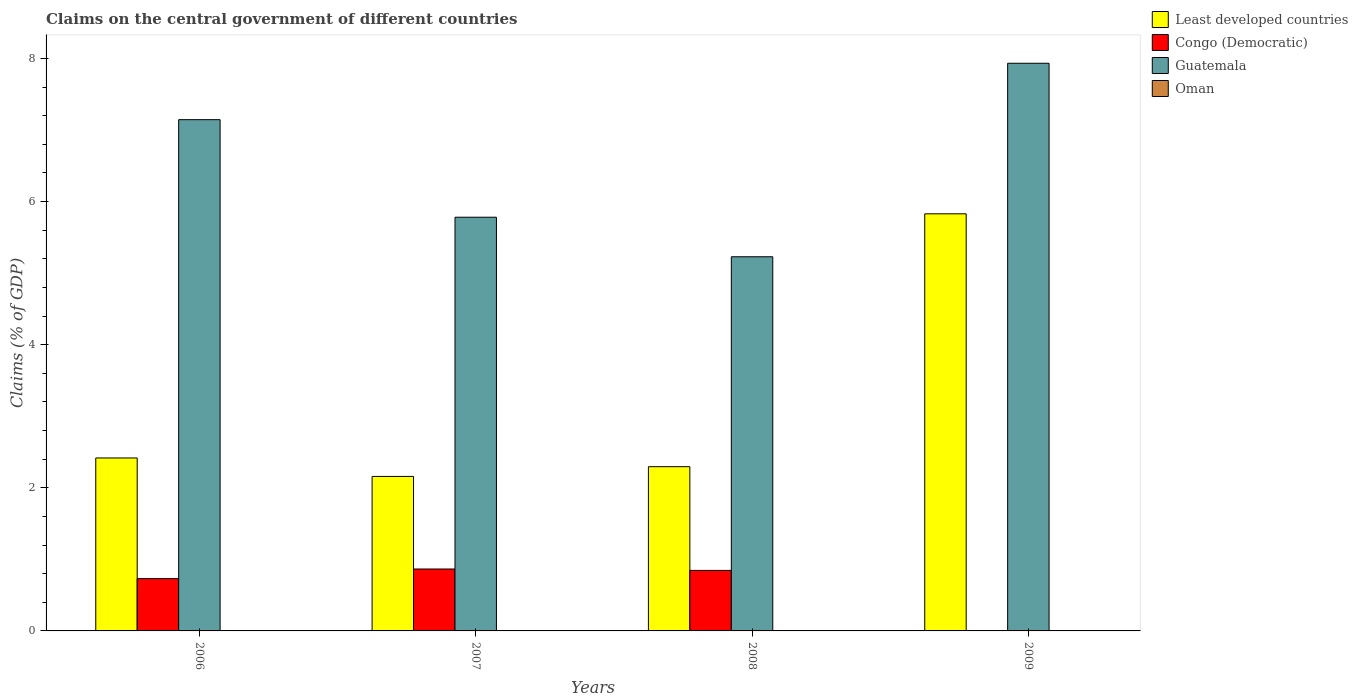How many groups of bars are there?
Your answer should be very brief. 4. Are the number of bars on each tick of the X-axis equal?
Your response must be concise. No. How many bars are there on the 2nd tick from the right?
Keep it short and to the point. 3. What is the percentage of GDP claimed on the central government in Guatemala in 2008?
Keep it short and to the point. 5.23. Across all years, what is the maximum percentage of GDP claimed on the central government in Congo (Democratic)?
Give a very brief answer. 0.87. Across all years, what is the minimum percentage of GDP claimed on the central government in Guatemala?
Provide a short and direct response. 5.23. In which year was the percentage of GDP claimed on the central government in Guatemala maximum?
Provide a short and direct response. 2009. What is the total percentage of GDP claimed on the central government in Congo (Democratic) in the graph?
Offer a terse response. 2.44. What is the difference between the percentage of GDP claimed on the central government in Congo (Democratic) in 2007 and that in 2008?
Your answer should be very brief. 0.02. What is the difference between the percentage of GDP claimed on the central government in Oman in 2007 and the percentage of GDP claimed on the central government in Congo (Democratic) in 2006?
Keep it short and to the point. -0.73. What is the average percentage of GDP claimed on the central government in Oman per year?
Your answer should be compact. 0. In the year 2006, what is the difference between the percentage of GDP claimed on the central government in Least developed countries and percentage of GDP claimed on the central government in Guatemala?
Your response must be concise. -4.73. What is the ratio of the percentage of GDP claimed on the central government in Guatemala in 2006 to that in 2009?
Make the answer very short. 0.9. Is the percentage of GDP claimed on the central government in Least developed countries in 2008 less than that in 2009?
Provide a short and direct response. Yes. Is the difference between the percentage of GDP claimed on the central government in Least developed countries in 2007 and 2008 greater than the difference between the percentage of GDP claimed on the central government in Guatemala in 2007 and 2008?
Keep it short and to the point. No. What is the difference between the highest and the second highest percentage of GDP claimed on the central government in Guatemala?
Provide a succinct answer. 0.79. What is the difference between the highest and the lowest percentage of GDP claimed on the central government in Congo (Democratic)?
Your answer should be compact. 0.87. In how many years, is the percentage of GDP claimed on the central government in Least developed countries greater than the average percentage of GDP claimed on the central government in Least developed countries taken over all years?
Make the answer very short. 1. Is the sum of the percentage of GDP claimed on the central government in Congo (Democratic) in 2007 and 2008 greater than the maximum percentage of GDP claimed on the central government in Oman across all years?
Provide a succinct answer. Yes. Is it the case that in every year, the sum of the percentage of GDP claimed on the central government in Oman and percentage of GDP claimed on the central government in Guatemala is greater than the sum of percentage of GDP claimed on the central government in Least developed countries and percentage of GDP claimed on the central government in Congo (Democratic)?
Offer a very short reply. No. Is it the case that in every year, the sum of the percentage of GDP claimed on the central government in Oman and percentage of GDP claimed on the central government in Congo (Democratic) is greater than the percentage of GDP claimed on the central government in Least developed countries?
Your answer should be compact. No. How many bars are there?
Offer a very short reply. 11. Are the values on the major ticks of Y-axis written in scientific E-notation?
Your answer should be compact. No. Does the graph contain grids?
Make the answer very short. No. How many legend labels are there?
Your response must be concise. 4. What is the title of the graph?
Give a very brief answer. Claims on the central government of different countries. What is the label or title of the X-axis?
Make the answer very short. Years. What is the label or title of the Y-axis?
Make the answer very short. Claims (% of GDP). What is the Claims (% of GDP) of Least developed countries in 2006?
Give a very brief answer. 2.42. What is the Claims (% of GDP) in Congo (Democratic) in 2006?
Offer a very short reply. 0.73. What is the Claims (% of GDP) of Guatemala in 2006?
Your response must be concise. 7.14. What is the Claims (% of GDP) in Least developed countries in 2007?
Offer a very short reply. 2.16. What is the Claims (% of GDP) in Congo (Democratic) in 2007?
Offer a terse response. 0.87. What is the Claims (% of GDP) of Guatemala in 2007?
Offer a very short reply. 5.78. What is the Claims (% of GDP) of Oman in 2007?
Give a very brief answer. 0. What is the Claims (% of GDP) of Least developed countries in 2008?
Make the answer very short. 2.3. What is the Claims (% of GDP) in Congo (Democratic) in 2008?
Your response must be concise. 0.85. What is the Claims (% of GDP) in Guatemala in 2008?
Ensure brevity in your answer.  5.23. What is the Claims (% of GDP) of Oman in 2008?
Give a very brief answer. 0. What is the Claims (% of GDP) in Least developed countries in 2009?
Your response must be concise. 5.83. What is the Claims (% of GDP) in Congo (Democratic) in 2009?
Your response must be concise. 0. What is the Claims (% of GDP) of Guatemala in 2009?
Make the answer very short. 7.93. What is the Claims (% of GDP) in Oman in 2009?
Provide a short and direct response. 0. Across all years, what is the maximum Claims (% of GDP) in Least developed countries?
Give a very brief answer. 5.83. Across all years, what is the maximum Claims (% of GDP) of Congo (Democratic)?
Ensure brevity in your answer.  0.87. Across all years, what is the maximum Claims (% of GDP) of Guatemala?
Keep it short and to the point. 7.93. Across all years, what is the minimum Claims (% of GDP) of Least developed countries?
Ensure brevity in your answer.  2.16. Across all years, what is the minimum Claims (% of GDP) in Guatemala?
Give a very brief answer. 5.23. What is the total Claims (% of GDP) of Least developed countries in the graph?
Your answer should be very brief. 12.7. What is the total Claims (% of GDP) in Congo (Democratic) in the graph?
Offer a terse response. 2.44. What is the total Claims (% of GDP) of Guatemala in the graph?
Make the answer very short. 26.09. What is the difference between the Claims (% of GDP) of Least developed countries in 2006 and that in 2007?
Provide a short and direct response. 0.26. What is the difference between the Claims (% of GDP) of Congo (Democratic) in 2006 and that in 2007?
Offer a very short reply. -0.13. What is the difference between the Claims (% of GDP) in Guatemala in 2006 and that in 2007?
Your answer should be very brief. 1.36. What is the difference between the Claims (% of GDP) of Least developed countries in 2006 and that in 2008?
Keep it short and to the point. 0.12. What is the difference between the Claims (% of GDP) of Congo (Democratic) in 2006 and that in 2008?
Give a very brief answer. -0.11. What is the difference between the Claims (% of GDP) in Guatemala in 2006 and that in 2008?
Ensure brevity in your answer.  1.92. What is the difference between the Claims (% of GDP) of Least developed countries in 2006 and that in 2009?
Offer a terse response. -3.41. What is the difference between the Claims (% of GDP) of Guatemala in 2006 and that in 2009?
Your answer should be compact. -0.79. What is the difference between the Claims (% of GDP) of Least developed countries in 2007 and that in 2008?
Ensure brevity in your answer.  -0.14. What is the difference between the Claims (% of GDP) in Congo (Democratic) in 2007 and that in 2008?
Your response must be concise. 0.02. What is the difference between the Claims (% of GDP) of Guatemala in 2007 and that in 2008?
Give a very brief answer. 0.55. What is the difference between the Claims (% of GDP) of Least developed countries in 2007 and that in 2009?
Make the answer very short. -3.67. What is the difference between the Claims (% of GDP) in Guatemala in 2007 and that in 2009?
Offer a very short reply. -2.15. What is the difference between the Claims (% of GDP) of Least developed countries in 2008 and that in 2009?
Offer a terse response. -3.53. What is the difference between the Claims (% of GDP) in Guatemala in 2008 and that in 2009?
Keep it short and to the point. -2.7. What is the difference between the Claims (% of GDP) in Least developed countries in 2006 and the Claims (% of GDP) in Congo (Democratic) in 2007?
Provide a succinct answer. 1.55. What is the difference between the Claims (% of GDP) in Least developed countries in 2006 and the Claims (% of GDP) in Guatemala in 2007?
Provide a short and direct response. -3.36. What is the difference between the Claims (% of GDP) of Congo (Democratic) in 2006 and the Claims (% of GDP) of Guatemala in 2007?
Keep it short and to the point. -5.05. What is the difference between the Claims (% of GDP) of Least developed countries in 2006 and the Claims (% of GDP) of Congo (Democratic) in 2008?
Your answer should be very brief. 1.57. What is the difference between the Claims (% of GDP) in Least developed countries in 2006 and the Claims (% of GDP) in Guatemala in 2008?
Provide a short and direct response. -2.81. What is the difference between the Claims (% of GDP) in Congo (Democratic) in 2006 and the Claims (% of GDP) in Guatemala in 2008?
Offer a very short reply. -4.5. What is the difference between the Claims (% of GDP) of Least developed countries in 2006 and the Claims (% of GDP) of Guatemala in 2009?
Provide a short and direct response. -5.52. What is the difference between the Claims (% of GDP) of Congo (Democratic) in 2006 and the Claims (% of GDP) of Guatemala in 2009?
Make the answer very short. -7.2. What is the difference between the Claims (% of GDP) of Least developed countries in 2007 and the Claims (% of GDP) of Congo (Democratic) in 2008?
Offer a terse response. 1.31. What is the difference between the Claims (% of GDP) of Least developed countries in 2007 and the Claims (% of GDP) of Guatemala in 2008?
Make the answer very short. -3.07. What is the difference between the Claims (% of GDP) of Congo (Democratic) in 2007 and the Claims (% of GDP) of Guatemala in 2008?
Provide a succinct answer. -4.36. What is the difference between the Claims (% of GDP) in Least developed countries in 2007 and the Claims (% of GDP) in Guatemala in 2009?
Give a very brief answer. -5.77. What is the difference between the Claims (% of GDP) of Congo (Democratic) in 2007 and the Claims (% of GDP) of Guatemala in 2009?
Provide a short and direct response. -7.07. What is the difference between the Claims (% of GDP) of Least developed countries in 2008 and the Claims (% of GDP) of Guatemala in 2009?
Your answer should be very brief. -5.64. What is the difference between the Claims (% of GDP) of Congo (Democratic) in 2008 and the Claims (% of GDP) of Guatemala in 2009?
Offer a terse response. -7.09. What is the average Claims (% of GDP) in Least developed countries per year?
Your response must be concise. 3.17. What is the average Claims (% of GDP) in Congo (Democratic) per year?
Your response must be concise. 0.61. What is the average Claims (% of GDP) in Guatemala per year?
Your answer should be very brief. 6.52. What is the average Claims (% of GDP) of Oman per year?
Your answer should be very brief. 0. In the year 2006, what is the difference between the Claims (% of GDP) in Least developed countries and Claims (% of GDP) in Congo (Democratic)?
Provide a short and direct response. 1.69. In the year 2006, what is the difference between the Claims (% of GDP) in Least developed countries and Claims (% of GDP) in Guatemala?
Offer a very short reply. -4.73. In the year 2006, what is the difference between the Claims (% of GDP) in Congo (Democratic) and Claims (% of GDP) in Guatemala?
Provide a succinct answer. -6.41. In the year 2007, what is the difference between the Claims (% of GDP) in Least developed countries and Claims (% of GDP) in Congo (Democratic)?
Your response must be concise. 1.29. In the year 2007, what is the difference between the Claims (% of GDP) in Least developed countries and Claims (% of GDP) in Guatemala?
Keep it short and to the point. -3.62. In the year 2007, what is the difference between the Claims (% of GDP) in Congo (Democratic) and Claims (% of GDP) in Guatemala?
Give a very brief answer. -4.92. In the year 2008, what is the difference between the Claims (% of GDP) in Least developed countries and Claims (% of GDP) in Congo (Democratic)?
Your answer should be very brief. 1.45. In the year 2008, what is the difference between the Claims (% of GDP) in Least developed countries and Claims (% of GDP) in Guatemala?
Your answer should be very brief. -2.93. In the year 2008, what is the difference between the Claims (% of GDP) in Congo (Democratic) and Claims (% of GDP) in Guatemala?
Give a very brief answer. -4.38. In the year 2009, what is the difference between the Claims (% of GDP) in Least developed countries and Claims (% of GDP) in Guatemala?
Your answer should be compact. -2.1. What is the ratio of the Claims (% of GDP) in Least developed countries in 2006 to that in 2007?
Your answer should be very brief. 1.12. What is the ratio of the Claims (% of GDP) in Congo (Democratic) in 2006 to that in 2007?
Make the answer very short. 0.84. What is the ratio of the Claims (% of GDP) of Guatemala in 2006 to that in 2007?
Ensure brevity in your answer.  1.24. What is the ratio of the Claims (% of GDP) in Least developed countries in 2006 to that in 2008?
Your answer should be compact. 1.05. What is the ratio of the Claims (% of GDP) in Congo (Democratic) in 2006 to that in 2008?
Give a very brief answer. 0.86. What is the ratio of the Claims (% of GDP) of Guatemala in 2006 to that in 2008?
Ensure brevity in your answer.  1.37. What is the ratio of the Claims (% of GDP) in Least developed countries in 2006 to that in 2009?
Your answer should be very brief. 0.41. What is the ratio of the Claims (% of GDP) in Guatemala in 2006 to that in 2009?
Your response must be concise. 0.9. What is the ratio of the Claims (% of GDP) of Least developed countries in 2007 to that in 2008?
Offer a terse response. 0.94. What is the ratio of the Claims (% of GDP) in Guatemala in 2007 to that in 2008?
Your response must be concise. 1.11. What is the ratio of the Claims (% of GDP) of Least developed countries in 2007 to that in 2009?
Provide a succinct answer. 0.37. What is the ratio of the Claims (% of GDP) of Guatemala in 2007 to that in 2009?
Offer a very short reply. 0.73. What is the ratio of the Claims (% of GDP) of Least developed countries in 2008 to that in 2009?
Give a very brief answer. 0.39. What is the ratio of the Claims (% of GDP) of Guatemala in 2008 to that in 2009?
Your answer should be very brief. 0.66. What is the difference between the highest and the second highest Claims (% of GDP) of Least developed countries?
Ensure brevity in your answer.  3.41. What is the difference between the highest and the second highest Claims (% of GDP) in Congo (Democratic)?
Provide a succinct answer. 0.02. What is the difference between the highest and the second highest Claims (% of GDP) in Guatemala?
Give a very brief answer. 0.79. What is the difference between the highest and the lowest Claims (% of GDP) in Least developed countries?
Your answer should be compact. 3.67. What is the difference between the highest and the lowest Claims (% of GDP) in Congo (Democratic)?
Offer a terse response. 0.87. What is the difference between the highest and the lowest Claims (% of GDP) in Guatemala?
Provide a succinct answer. 2.7. 